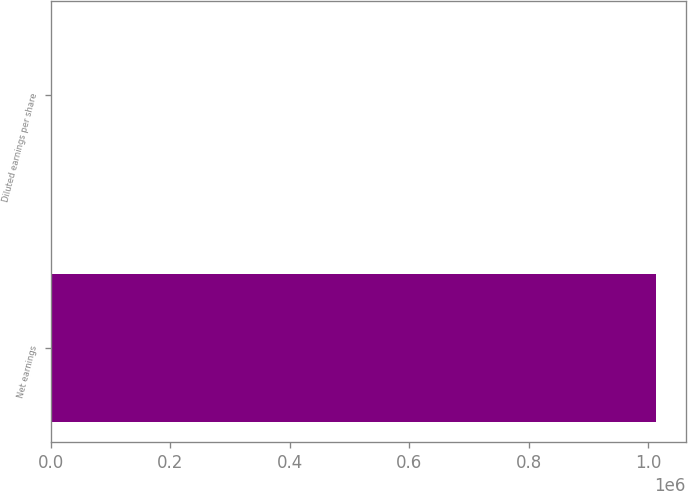<chart> <loc_0><loc_0><loc_500><loc_500><bar_chart><fcel>Net earnings<fcel>Diluted earnings per share<nl><fcel>1.01214e+06<fcel>1.86<nl></chart> 